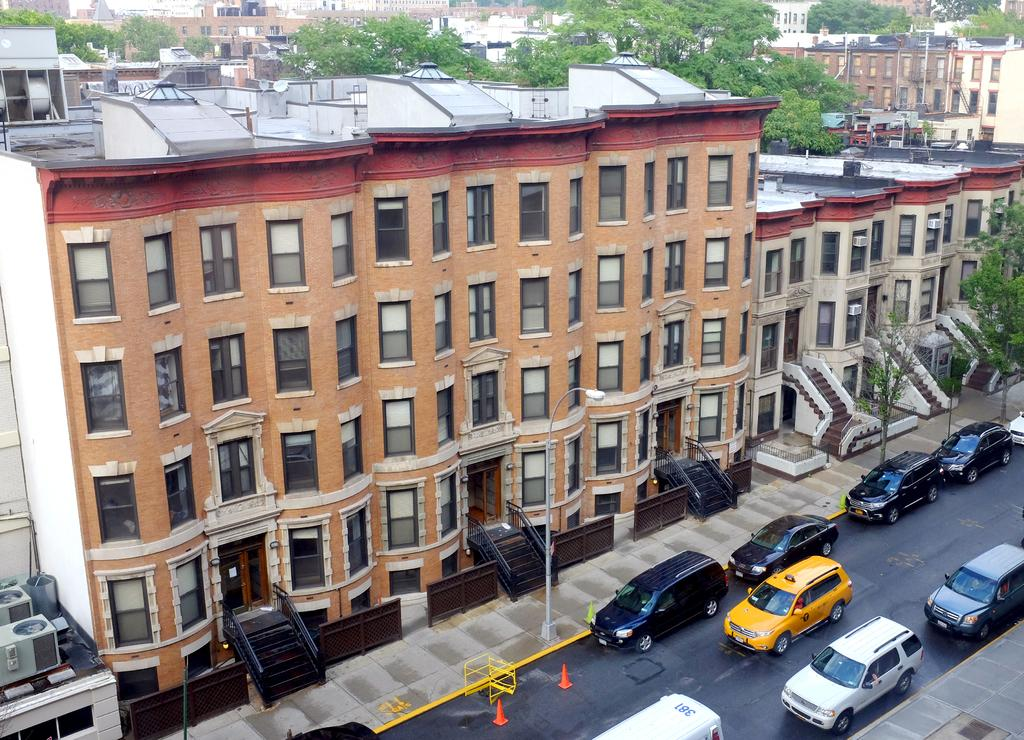What can be seen on the right side of the image? There are cars on the road on the right side of the image. What type of structures are present in the image? There are buildings with windows in the image. What natural elements can be seen in the image? There are trees visible in the image. What else can be seen in the background of the image? There are additional buildings in the background of the image. What type of frame is holding the tin in the image? There is no tin or frame present in the image. What type of journey is depicted in the image? The image does not depict a journey; it shows cars on the road, buildings, and trees. 